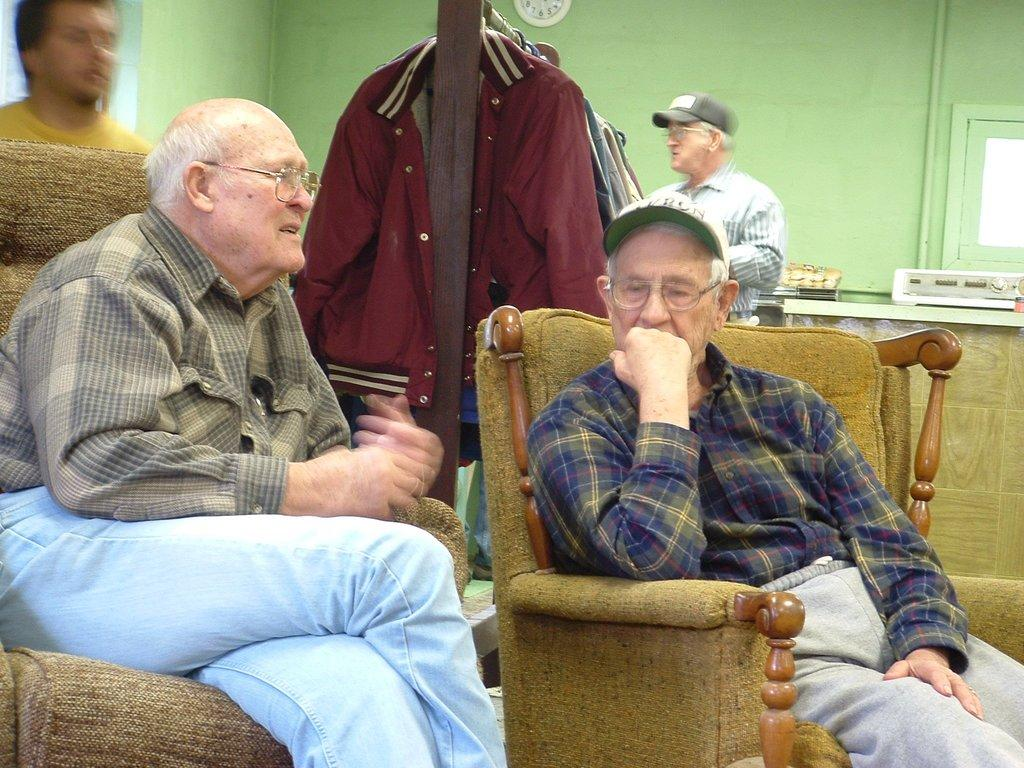How many men are present in the image? There are two men in the image. What are the men wearing? Both men are wearing spectacles. What are the men doing in the image? The men are sitting on chairs. What type of clothing is visible in the image? There are jackets visible in the image. Can you describe the background of the image? There are two men standing in the background. What is on the wall in the image? There is a clock on the wall. What other objects can be seen in the image? There are other objects present in the image, but their specific details are not mentioned in the provided facts. How many lizards are crawling on the apparatus in the image? There are no lizards or apparatus present in the image. What is the digestion process of the men in the image? The provided facts do not mention anything about the men's digestion process. 